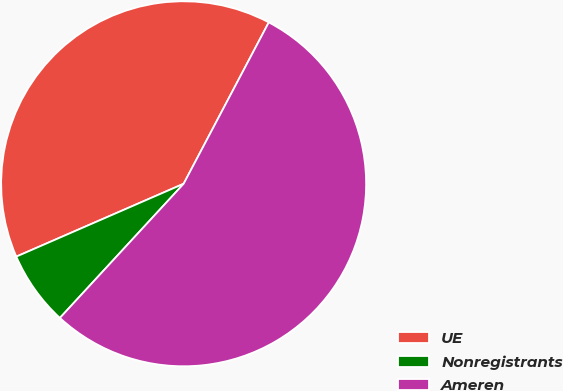<chart> <loc_0><loc_0><loc_500><loc_500><pie_chart><fcel>UE<fcel>Nonregistrants<fcel>Ameren<nl><fcel>39.26%<fcel>6.61%<fcel>54.13%<nl></chart> 